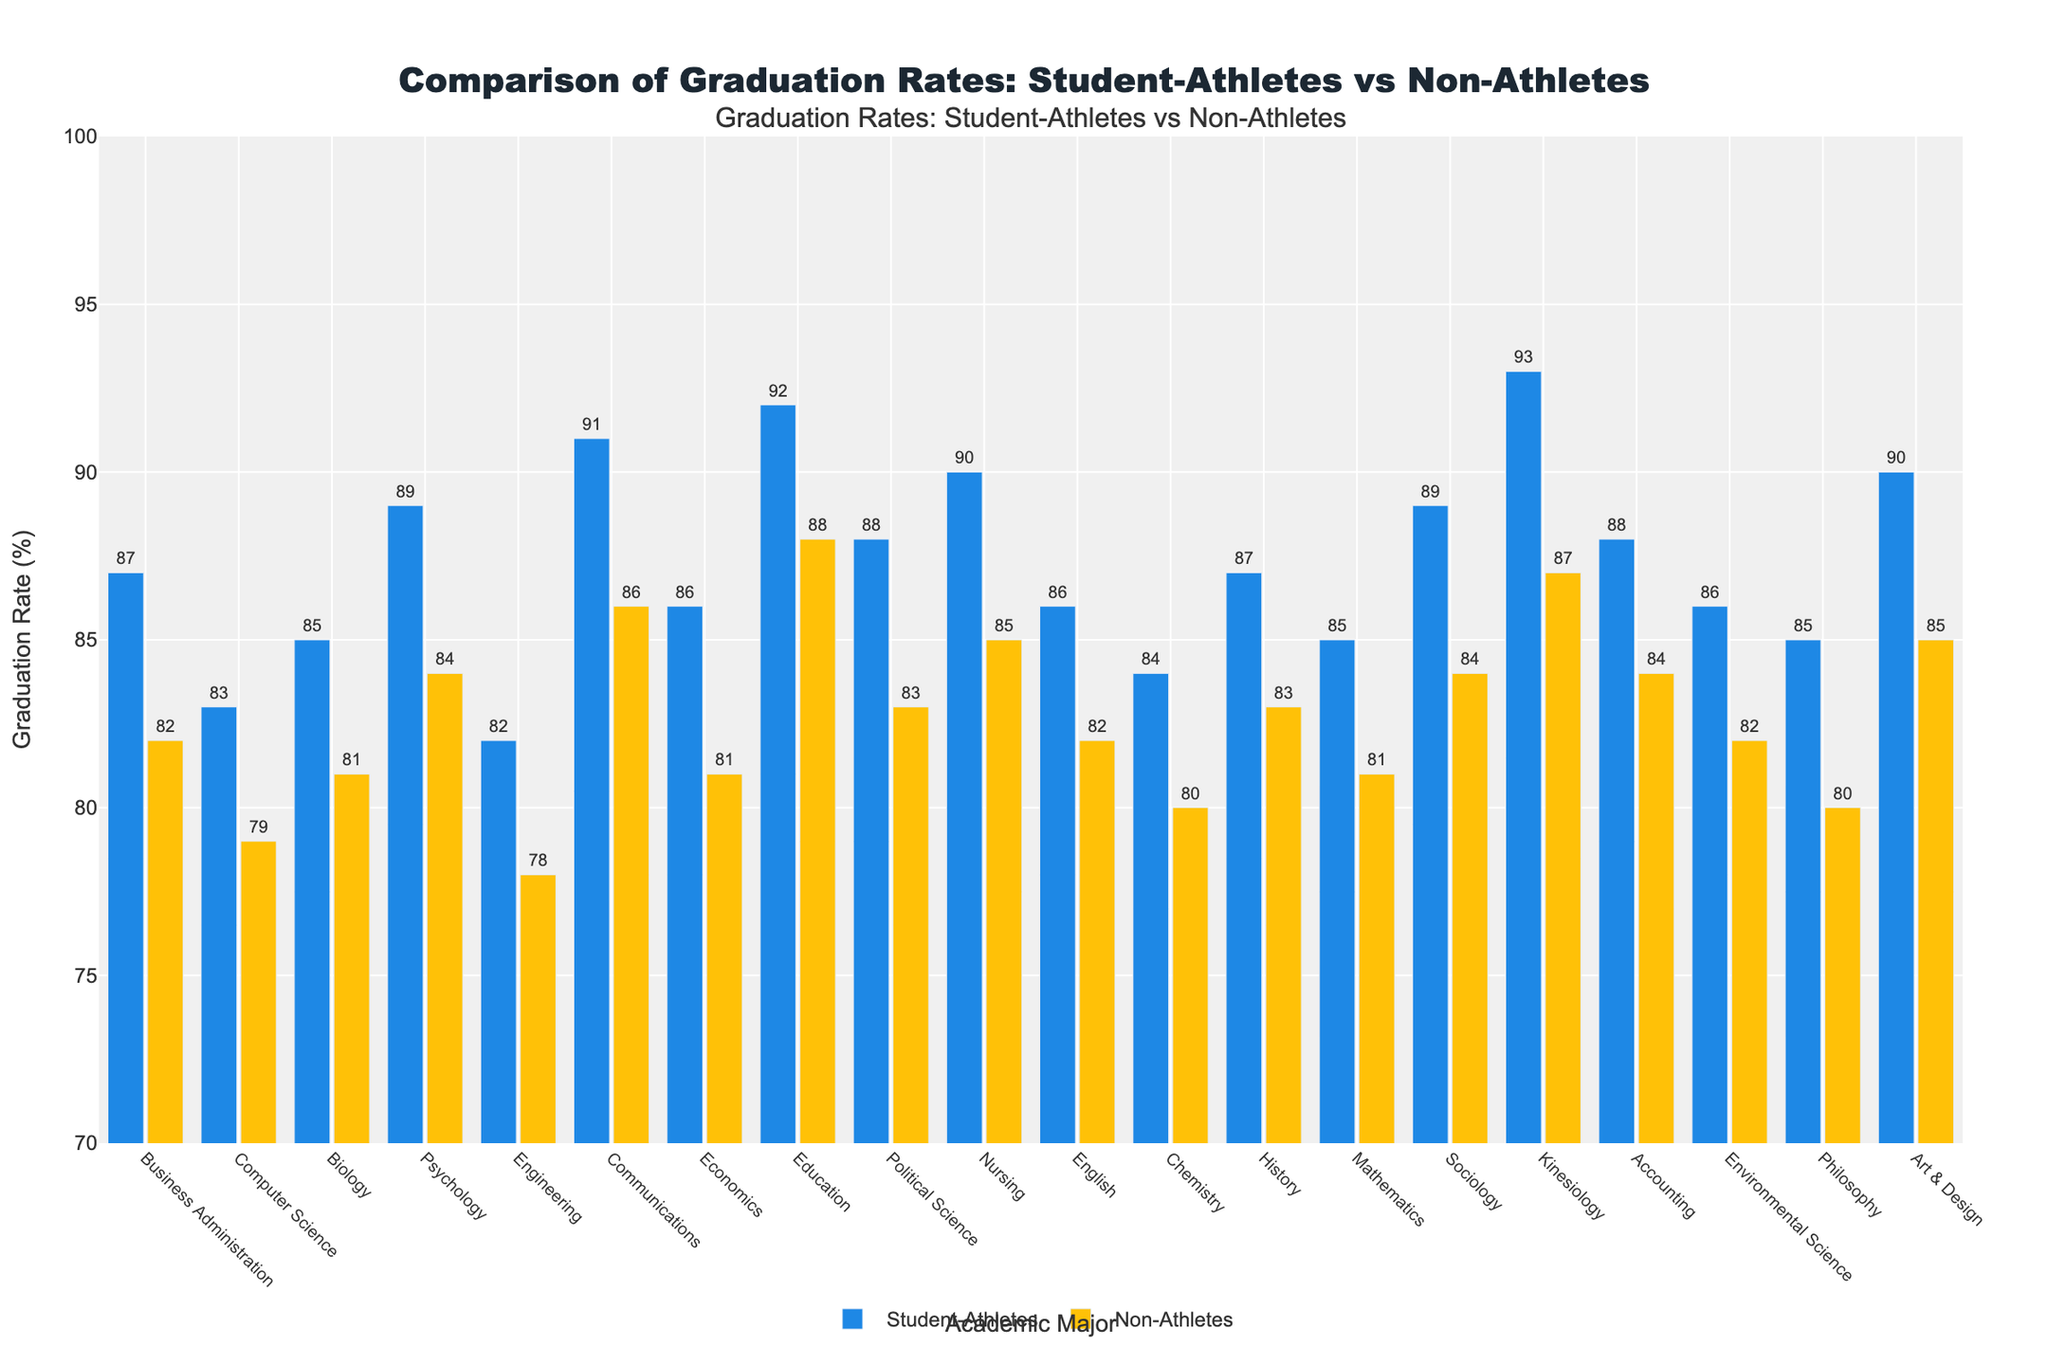Which major has the highest graduation rate for student-athletes? By looking at the height of the bars representing student-athletes, we can see that Kinesiology has the highest graduation rate at 93%.
Answer: Kinesiology Which major has the lowest graduation rate for non-athletes? By inspecting the bars representing non-athletes, we observe that Engineering has the lowest graduation rate at 78%.
Answer: Engineering What is the graduation rate difference between student-athletes and non-athletes in Computer Science? The graduation rate for student-athletes in Computer Science is 83%, and for non-athletes it is 79%. The difference is 83% - 79% = 4%.
Answer: 4% In which major is the graduation rate of student-athletes exactly equal to 85%? By checking the bars labeled with the graduation rates for all majors, we find that the rate of 85% for student-athletes corresponds to Biology, Mathematics, and Philosophy.
Answer: Biology, Mathematics, Philosophy What is the average graduation rate for student-athletes in the majors of Business Administration, Communications, and Nursing? The graduation rates are 87% for Business Administration, 91% for Communications, and 90% for Nursing. The average is (87% + 91% + 90%) / 3 = 89.33%.
Answer: 89.33% How does the graduation rate for student-athletes in Psychology compare to that in Political Science? The graduation rate for student-athletes in Psychology is 89%, and in Political Science, it is 88%. Psychology has a slightly higher rate than Political Science by 1%.
Answer: Psychology has a higher rate by 1% Which majors show a graduation rate of 84% for non-athletes? Checking the bars labeled with 84% for non-athletes, we find that Psychology, Sociology, and Accounting have this graduation rate.
Answer: Psychology, Sociology, Accounting What is the combined graduation rate for student-athletes in Business Administration and Engineering? The graduation rates are 87% for Business Administration and 82% for Engineering. The combined rate is 87% + 82% = 169%.
Answer: 169% Which major has the smallest difference in graduation rates between student-athletes and non-athletes? By calculating the differences for each major, we find that Computer Science has the smallest difference with 83% for student-athletes and 79% for non-athletes, resulting in a difference of 4%.
Answer: Computer Science Is there any major where the graduation rate for non-athletes is higher than that for student-athletes? By comparing all pairs of bars, we see that in no major is the graduation rate for non-athletes higher than that for student-athletes.
Answer: No 